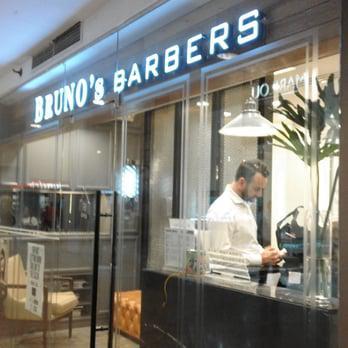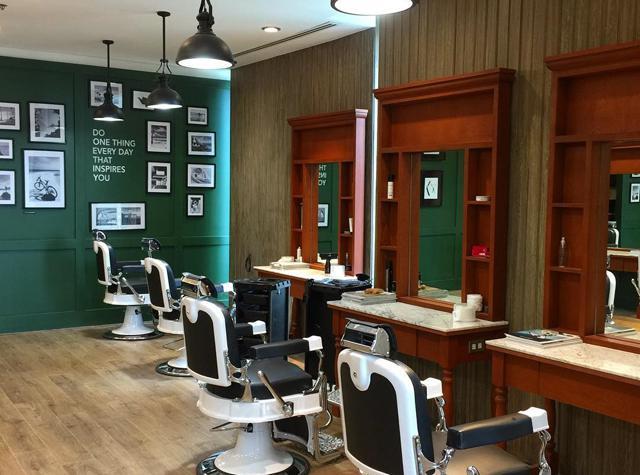The first image is the image on the left, the second image is the image on the right. Evaluate the accuracy of this statement regarding the images: "There is only one barber chair in the left image.". Is it true? Answer yes or no. No. The first image is the image on the left, the second image is the image on the right. Evaluate the accuracy of this statement regarding the images: "There is at least five people's reflections in the mirror.". Is it true? Answer yes or no. No. 